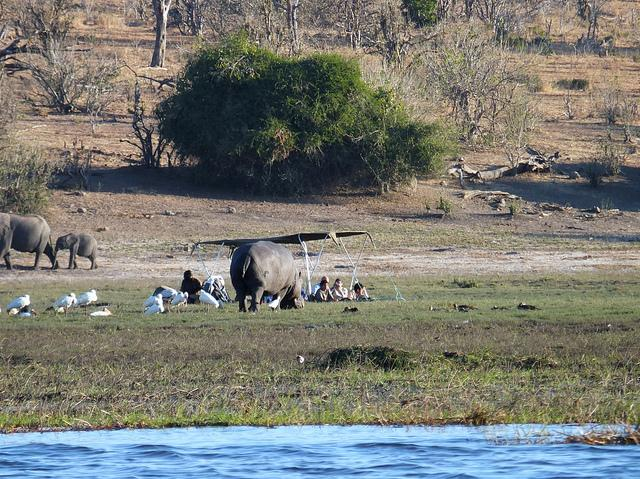Who are in the most danger?

Choices:
A) hippopotamus
B) humans
C) birds
D) elephants humans 